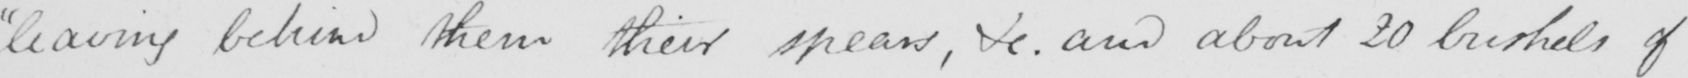Transcribe the text shown in this historical manuscript line. leaving behind them their spears, &c. and about 20 bushels of 